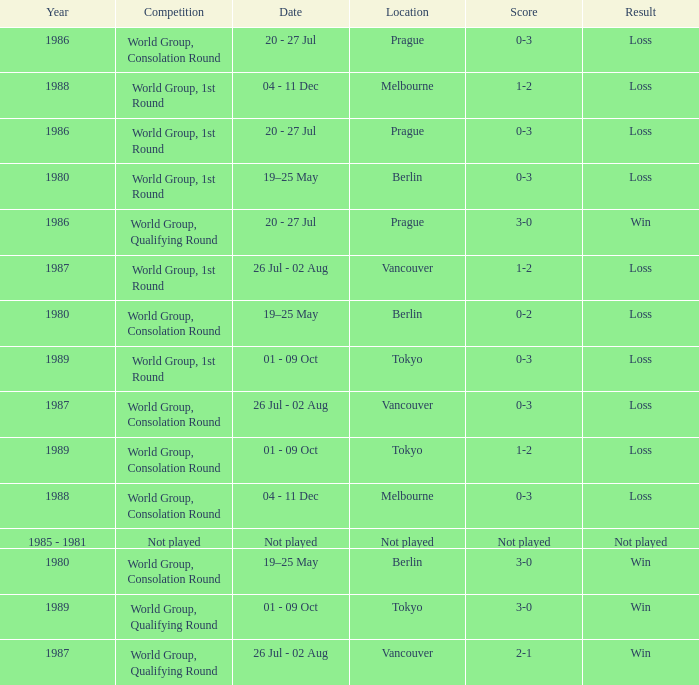What is the competition in tokyo with the result loss? World Group, 1st Round, World Group, Consolation Round. 